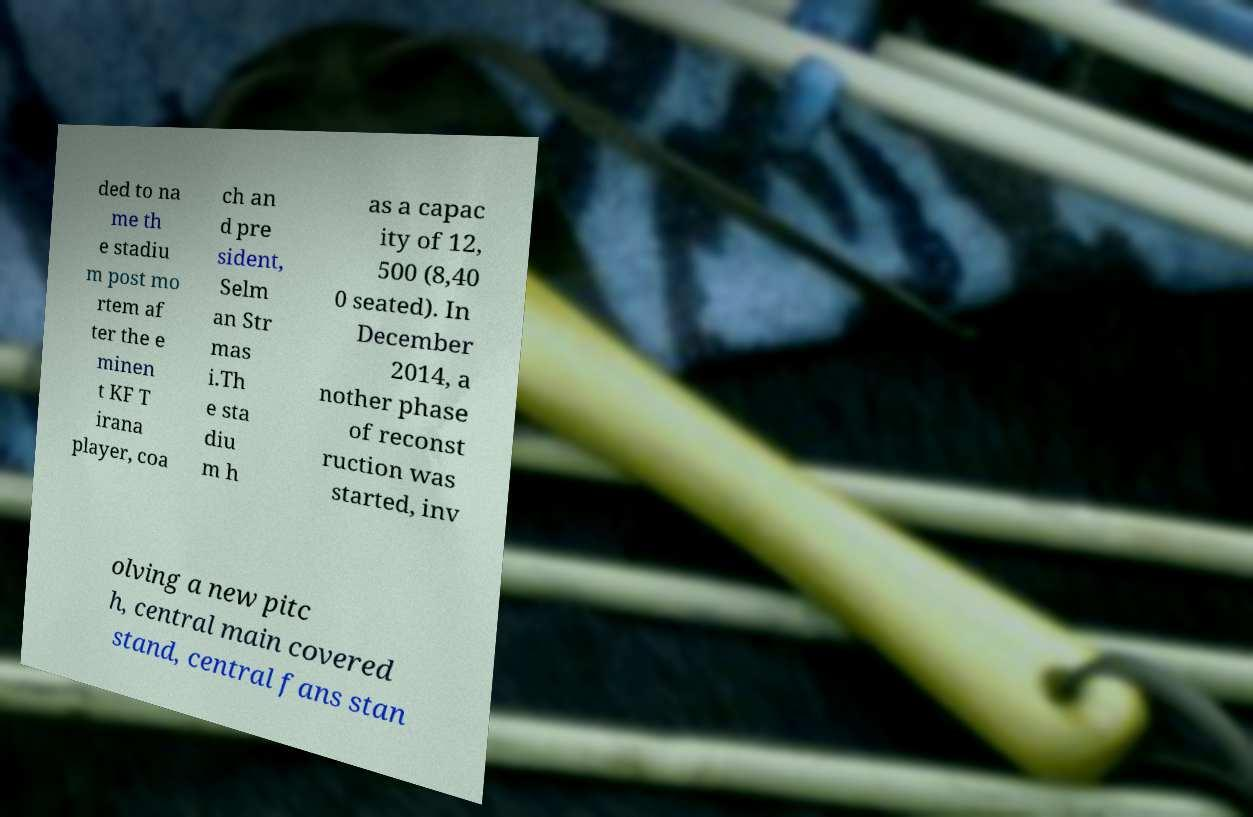Please read and relay the text visible in this image. What does it say? ded to na me th e stadiu m post mo rtem af ter the e minen t KF T irana player, coa ch an d pre sident, Selm an Str mas i.Th e sta diu m h as a capac ity of 12, 500 (8,40 0 seated). In December 2014, a nother phase of reconst ruction was started, inv olving a new pitc h, central main covered stand, central fans stan 